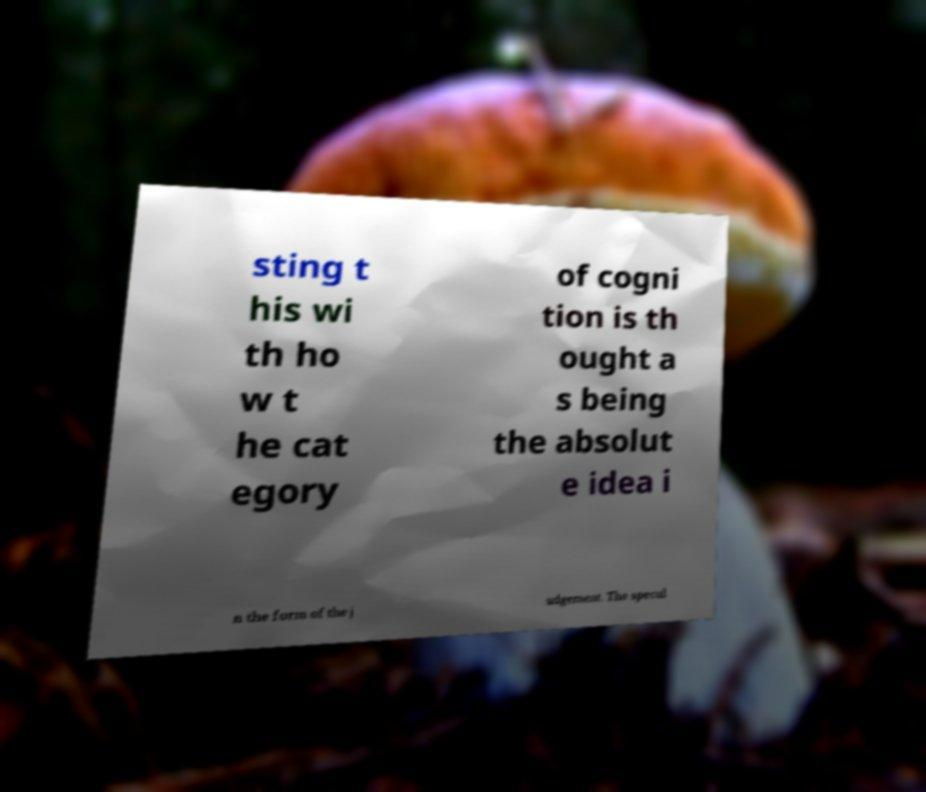Please read and relay the text visible in this image. What does it say? sting t his wi th ho w t he cat egory of cogni tion is th ought a s being the absolut e idea i n the form of the j udgement. The specul 